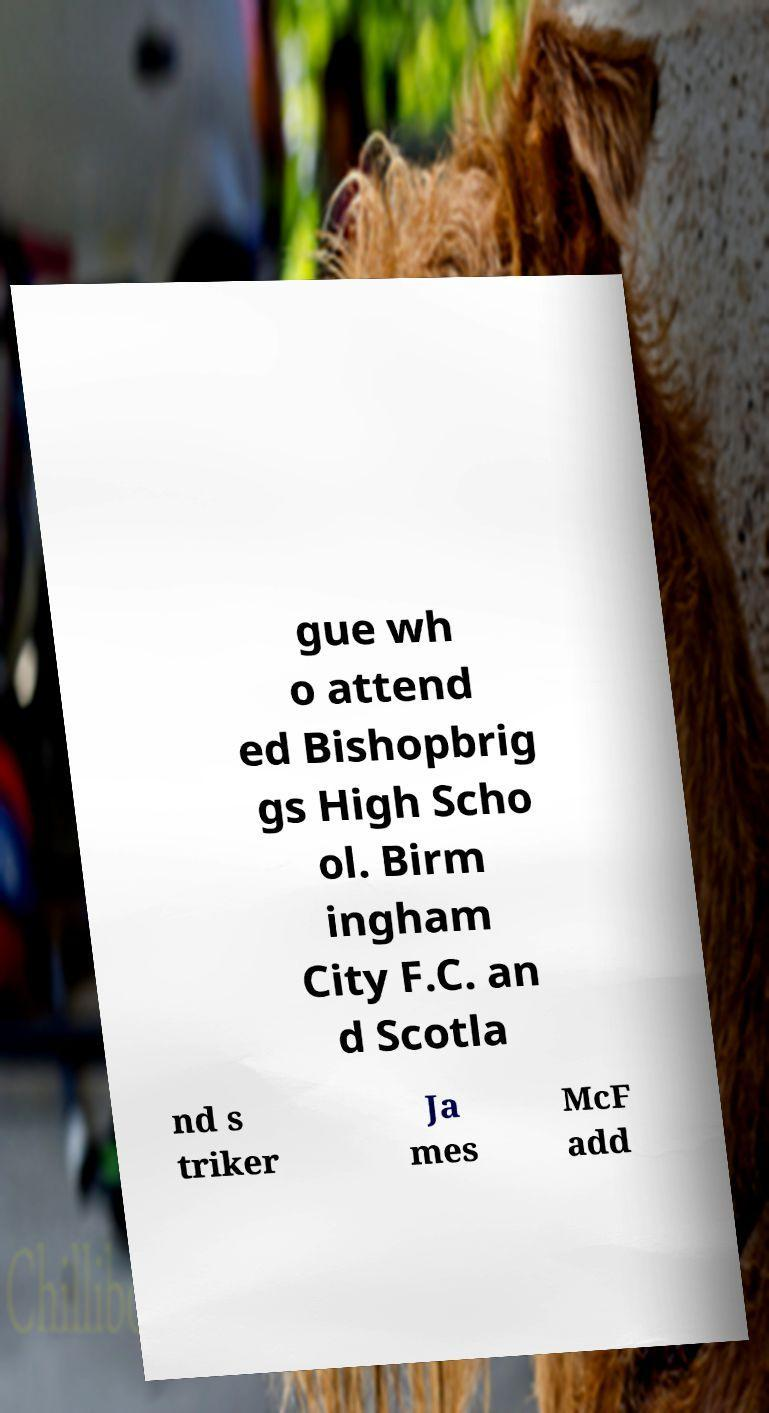Please identify and transcribe the text found in this image. gue wh o attend ed Bishopbrig gs High Scho ol. Birm ingham City F.C. an d Scotla nd s triker Ja mes McF add 